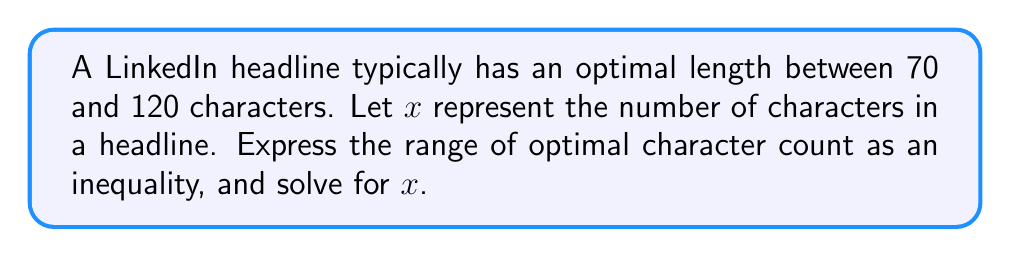Can you solve this math problem? To solve this problem, we'll follow these steps:

1) The optimal range is between 70 and 120 characters. In mathematical terms, this means $x$ should be greater than or equal to 70 and less than or equal to 120.

2) We can express this as a compound inequality:

   $$ 70 \leq x \leq 120 $$

3) This inequality already gives us the solution for $x$. It means that $x$ can be any number from 70 to 120, inclusive.

4) In set notation, we could write this as:

   $$ x \in [70, 120] $$

   where $[70, 120]$ represents the closed interval from 70 to 120.

5) This range allows for flexibility in crafting headlines while staying within the optimal character count for visibility on LinkedIn.
Answer: $70 \leq x \leq 120$, where $x$ is the number of characters in the headline. 